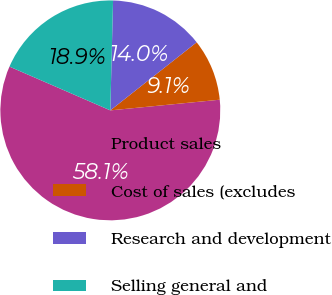Convert chart. <chart><loc_0><loc_0><loc_500><loc_500><pie_chart><fcel>Product sales<fcel>Cost of sales (excludes<fcel>Research and development<fcel>Selling general and<nl><fcel>58.07%<fcel>9.08%<fcel>13.98%<fcel>18.88%<nl></chart> 